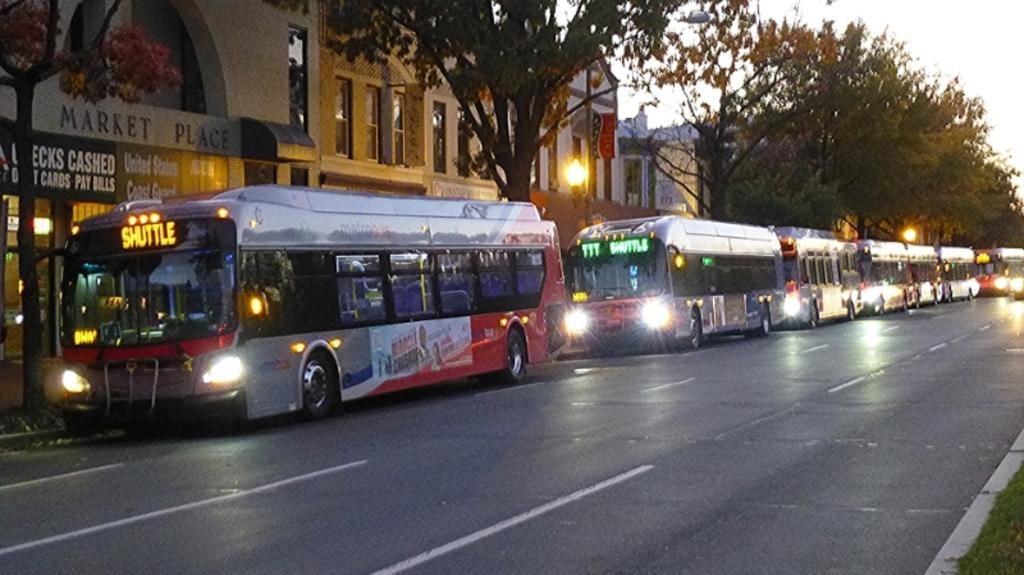What type of vehicles can be seen on the road in the image? There are buses on the road in the image. What can be seen in the background of the image? The sky, clouds, trees, buildings, a wall, windows, banners, street lights, and grass are visible in the background of the image. What type of lumber is being used to construct the table in the image? There is no table present in the image, so it is not possible to determine the type of lumber being used. 